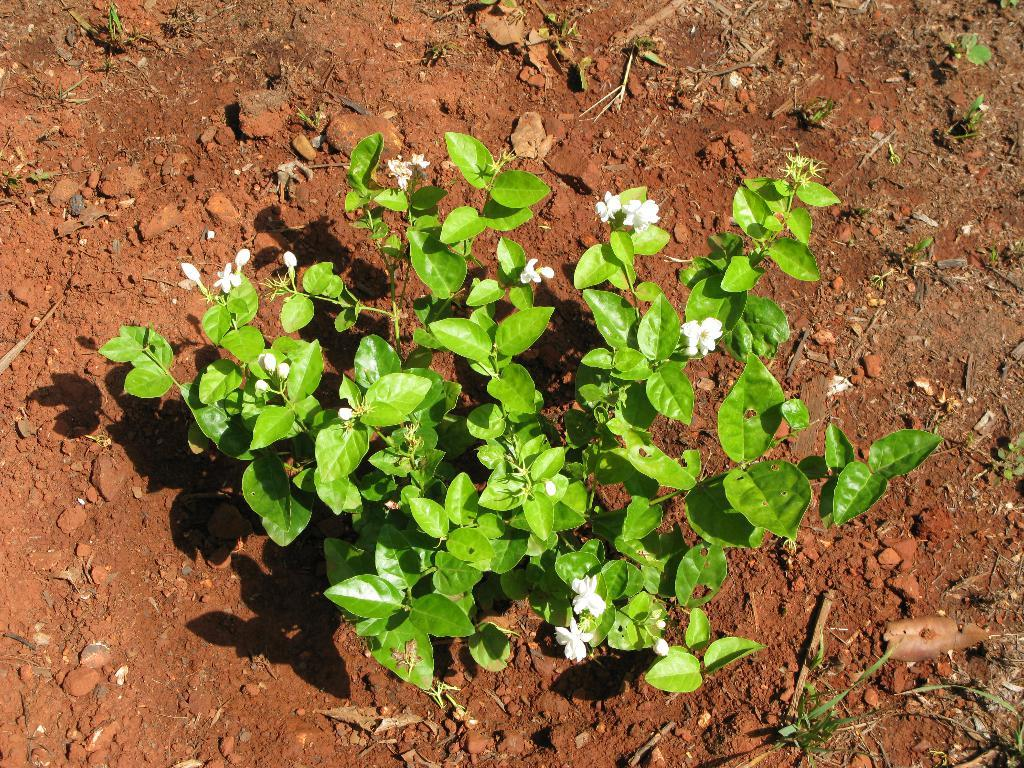What type of plant is in the image? There is a plant in the image, and it has flowers and buds. What can be seen on the ground in the image? Stones and grass are present on the ground in the image. Can you describe the plant's growth stage? The plant has both flowers and buds, indicating that it is in a stage of blooming. What type of book is the secretary reading in the image? There is no book or secretary present in the image; it features a plant with flowers and buds, stones, and grass on the ground. 